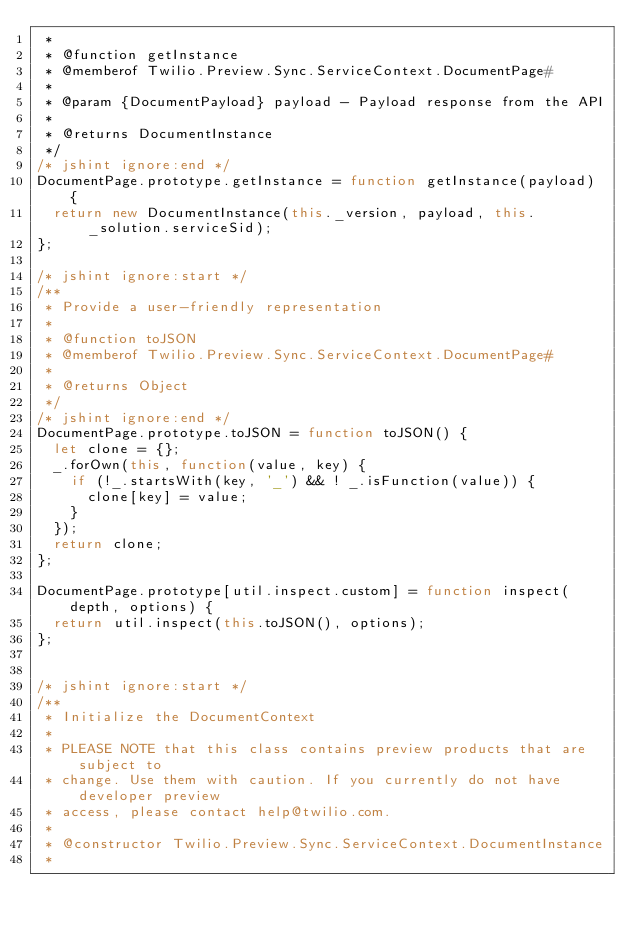Convert code to text. <code><loc_0><loc_0><loc_500><loc_500><_JavaScript_> *
 * @function getInstance
 * @memberof Twilio.Preview.Sync.ServiceContext.DocumentPage#
 *
 * @param {DocumentPayload} payload - Payload response from the API
 *
 * @returns DocumentInstance
 */
/* jshint ignore:end */
DocumentPage.prototype.getInstance = function getInstance(payload) {
  return new DocumentInstance(this._version, payload, this._solution.serviceSid);
};

/* jshint ignore:start */
/**
 * Provide a user-friendly representation
 *
 * @function toJSON
 * @memberof Twilio.Preview.Sync.ServiceContext.DocumentPage#
 *
 * @returns Object
 */
/* jshint ignore:end */
DocumentPage.prototype.toJSON = function toJSON() {
  let clone = {};
  _.forOwn(this, function(value, key) {
    if (!_.startsWith(key, '_') && ! _.isFunction(value)) {
      clone[key] = value;
    }
  });
  return clone;
};

DocumentPage.prototype[util.inspect.custom] = function inspect(depth, options) {
  return util.inspect(this.toJSON(), options);
};


/* jshint ignore:start */
/**
 * Initialize the DocumentContext
 *
 * PLEASE NOTE that this class contains preview products that are subject to
 * change. Use them with caution. If you currently do not have developer preview
 * access, please contact help@twilio.com.
 *
 * @constructor Twilio.Preview.Sync.ServiceContext.DocumentInstance
 *</code> 